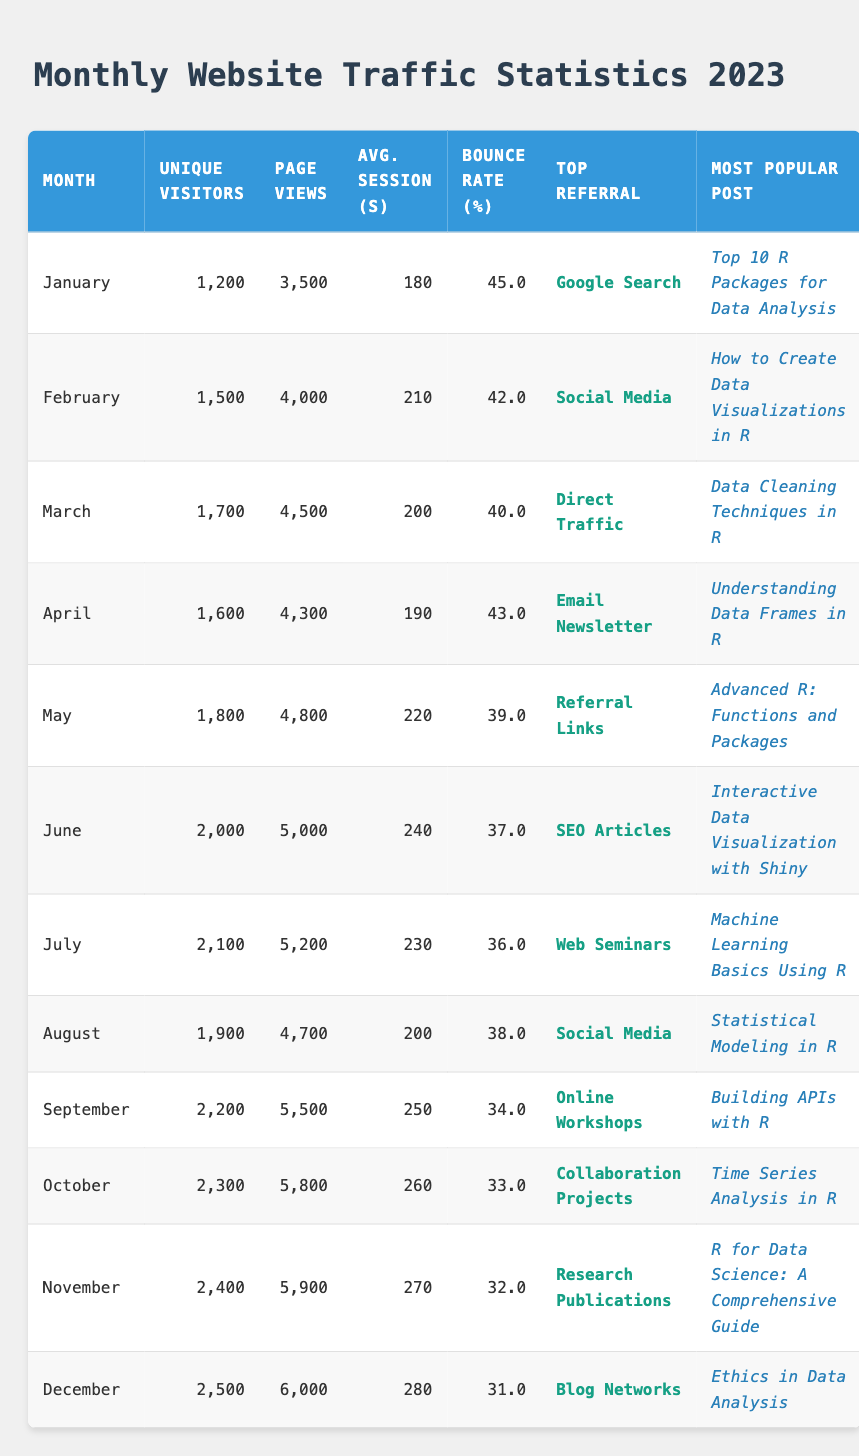What was the highest number of unique visitors achieved in a month? Looking through the table, the number of unique visitors reaches its peak in December, where there were 2500 unique visitors.
Answer: 2500 What is the average bounce rate for the first half of the year? For January to June, the bounce rates are 45.0, 42.0, 40.0, 43.0, 39.0, and 37.0. The total bounce rate is 45.0 + 42.0 + 40.0 + 43.0 + 39.0 + 37.0 = 246. There are 6 months, so the average is 246/6 = 41.0.
Answer: 41.0 Did the unique visitors increase every month? By examining the unique visitors column, it shows that the count ascends each month without any decrease from January to December.
Answer: Yes What was the month with the most page views, and how many were there? Looking across the table, each month has a different number of page views, and the highest is in December, with a total of 6000 page views.
Answer: December, 6000 How much did the average session duration increase from January to December? The average session durations are 180 seconds for January and 280 seconds for December. The increase is calculated as 280 - 180 = 100 seconds.
Answer: 100 seconds Which month had the highest number of page views per unique visitor? To find this, calculate the page views to unique visitors ratio for each month. For November: 5900/2400 = 2.46, for December: 6000/2500 = 2.40. The highest ratio is for November, yielding approximately 2.46 page views per visitor.
Answer: November, approximately 2.46 What was the most popular post in the month of August? Checking the table, in August, the most popular post listed is "Statistical Modeling in R."
Answer: Statistical Modeling in R Was the top referral source in June the same as in July? By looking at the table, June’s top referral source is "SEO Articles" and July's is "Web Seminars," so they are different.
Answer: No 